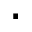<formula> <loc_0><loc_0><loc_500><loc_500>.</formula> 